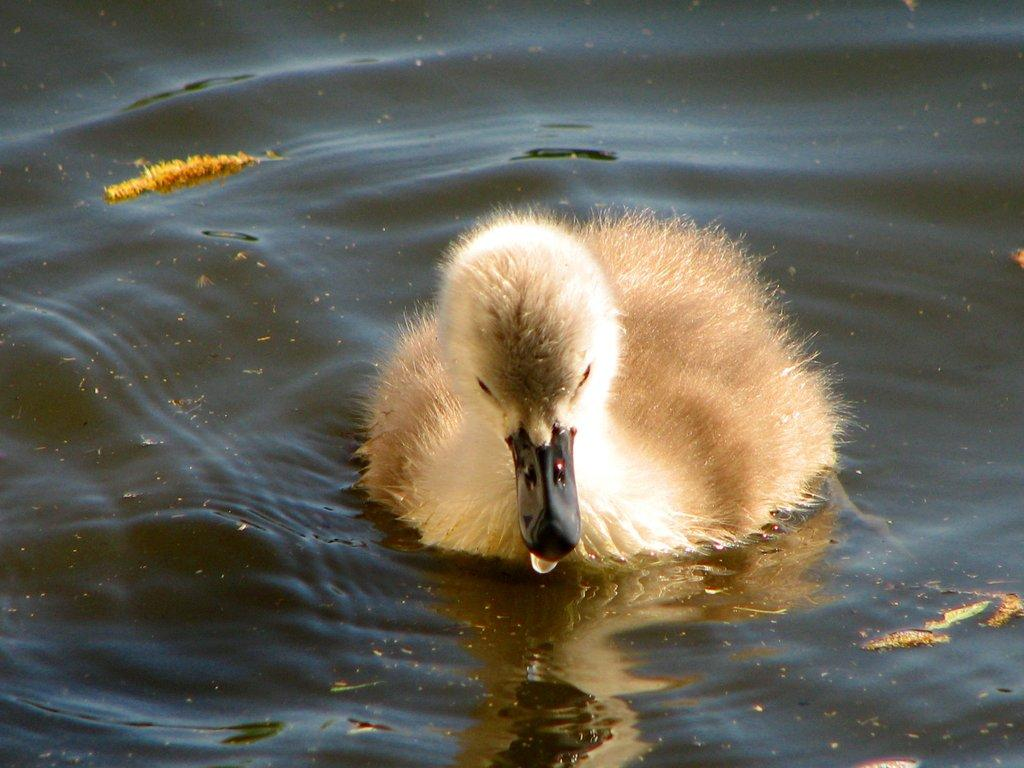What animal is present in the image? There is a duck in the image. What is the duck doing in the image? The duck is swimming in the water. What color is the duck in the image? The duck is white in color. Where is the scarecrow located in the image? There is no scarecrow present in the image. What type of bat can be seen flying in the image? There is no bat present in the image. 